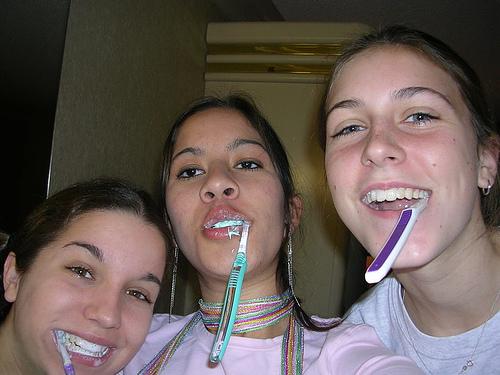What color is the right toothbrush?
Concise answer only. Purple. Which girl is taking the photo?
Give a very brief answer. Middle. Are there having fun while brushing their teeth?
Quick response, please. Yes. What is the ethnicity of these women?
Answer briefly. White. Are they eating lollipop?
Write a very short answer. No. 